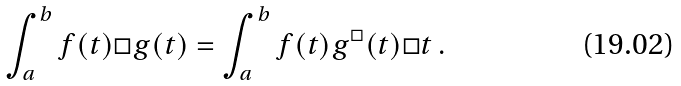Convert formula to latex. <formula><loc_0><loc_0><loc_500><loc_500>\int _ { a } ^ { b } f ( t ) \Box g ( t ) = \int _ { a } ^ { b } f ( t ) g ^ { \Box } ( t ) \Box t \, .</formula> 